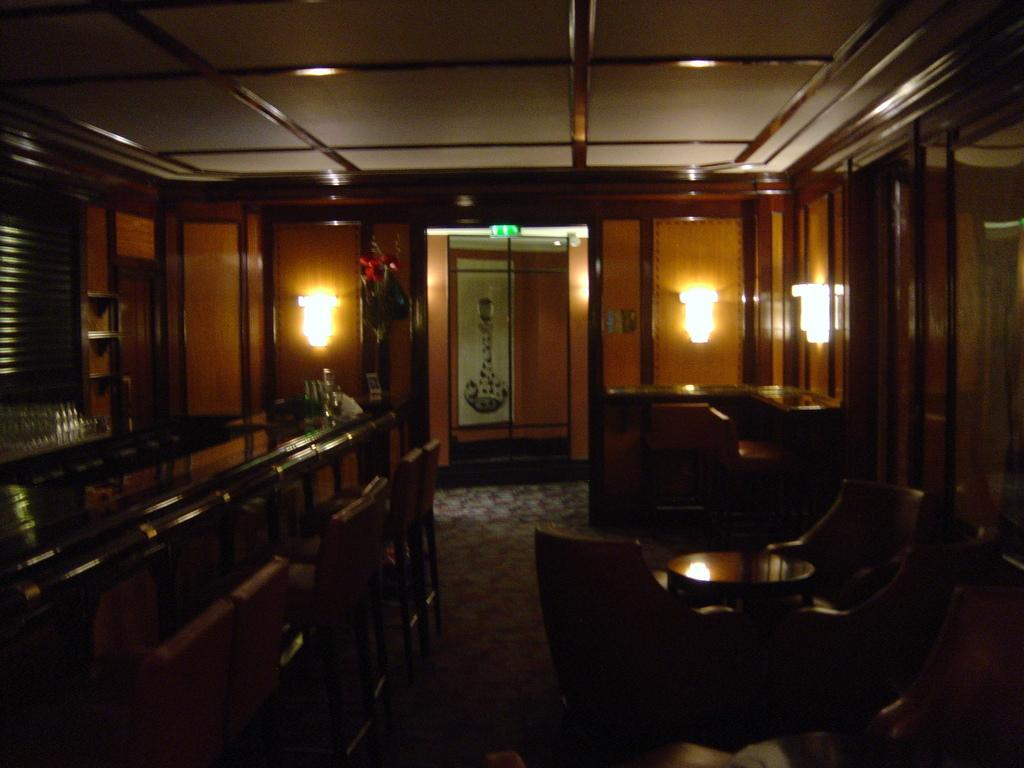What type of objects are attached to the wall in the image? There are lights on the wall. What type of furniture is inside the room? There are tables and chairs inside the room. Can you tell me how many clams are sitting on the chairs in the image? There are no clams present in the image; it features lights on the wall and furniture inside the room. What type of nerve is visible in the image? There is no nerve visible in the image. 